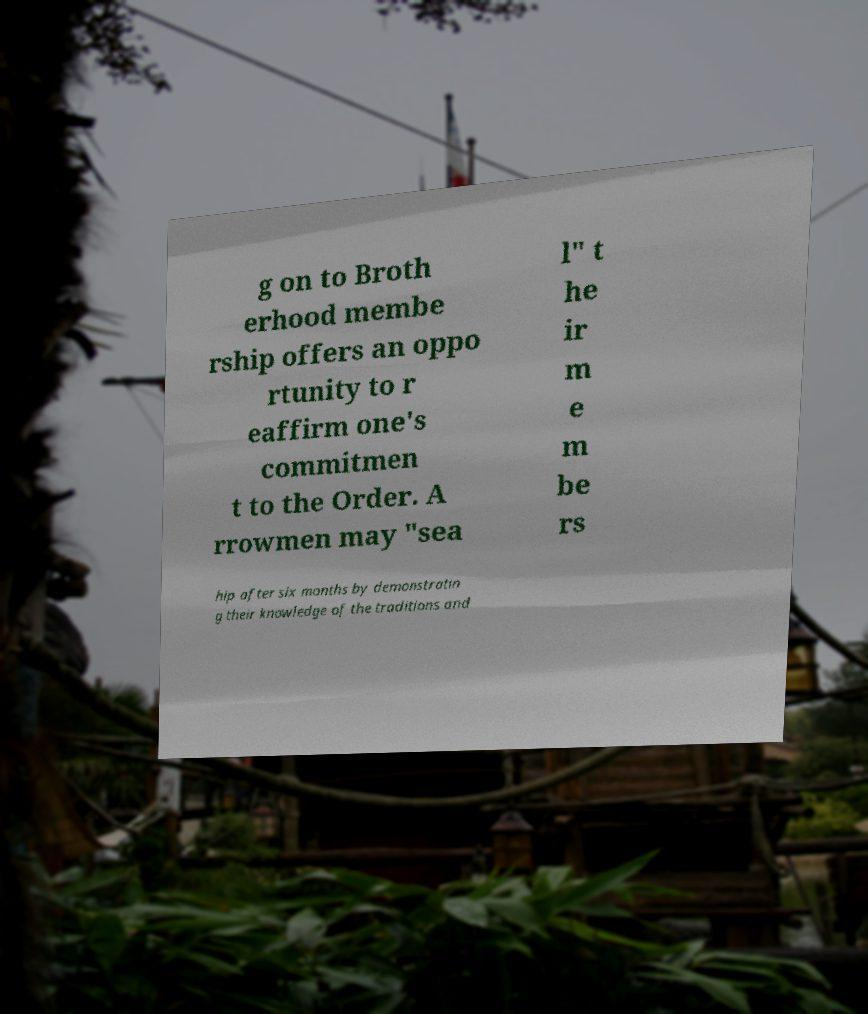Can you accurately transcribe the text from the provided image for me? g on to Broth erhood membe rship offers an oppo rtunity to r eaffirm one's commitmen t to the Order. A rrowmen may "sea l" t he ir m e m be rs hip after six months by demonstratin g their knowledge of the traditions and 